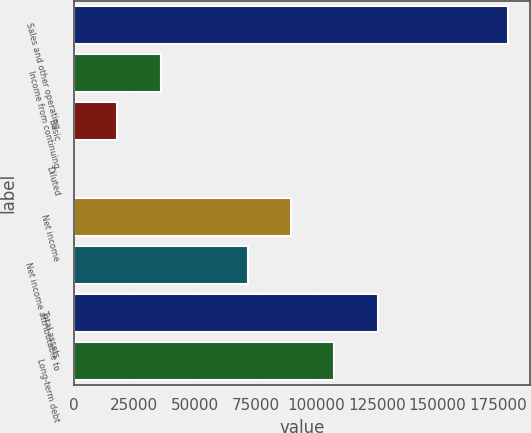Convert chart to OTSL. <chart><loc_0><loc_0><loc_500><loc_500><bar_chart><fcel>Sales and other operating<fcel>Income from continuing<fcel>Basic<fcel>Diluted<fcel>Net income<fcel>Net income attributable to<fcel>Total assets<fcel>Long-term debt<nl><fcel>179290<fcel>35863.1<fcel>17934.8<fcel>6.4<fcel>89648.2<fcel>71719.8<fcel>125505<fcel>107577<nl></chart> 